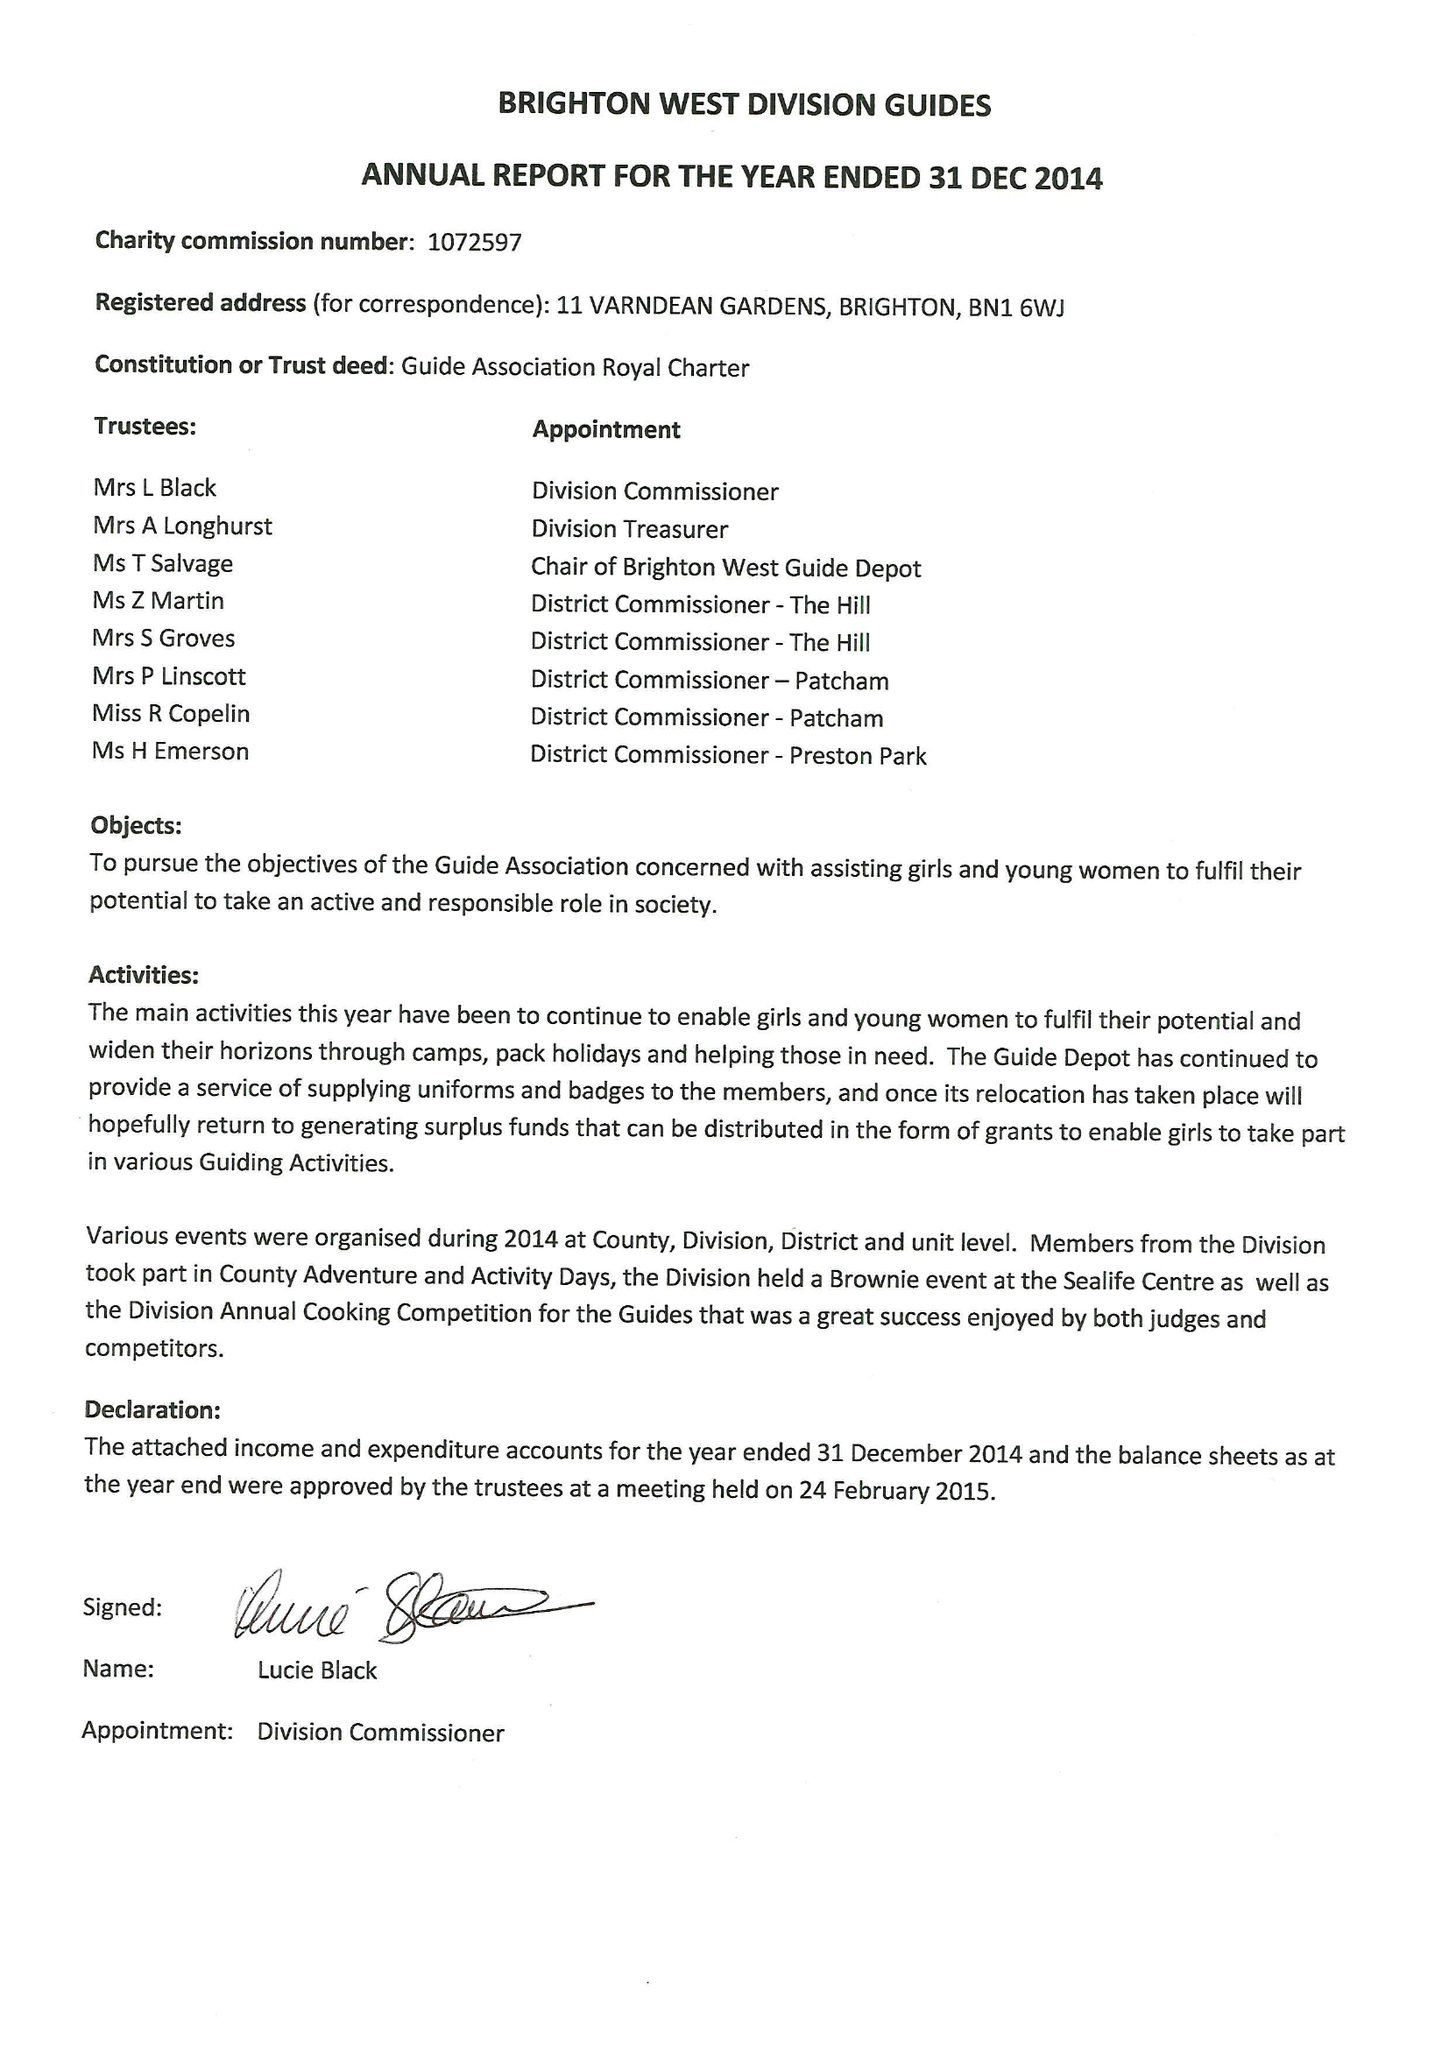What is the value for the spending_annually_in_british_pounds?
Answer the question using a single word or phrase. 33036.00 